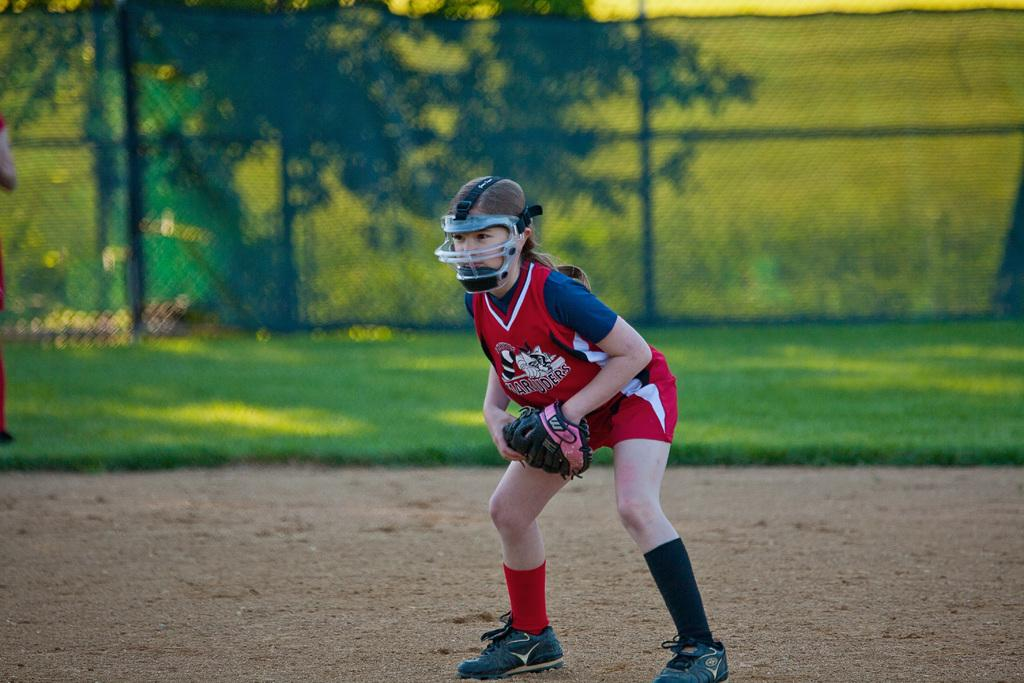What is the main subject in the foreground of the image? There is a woman in the foreground of the image. What is the woman doing in the image? The woman is standing in the image. What type of clothing or accessories is the woman wearing? The woman is wearing gloves, a helmet, and shoes in the image. What can be seen in the background of the image? There is greenery and fencing in the background of the image. What is visible at the woman's feet? The ground is visible in the foreground of the image. What type of scissors can be seen in the woman's hand in the image? There are no scissors visible in the woman's hand in the image. What type of jewel is the woman wearing around her neck in the image? There is no jewel visible around the woman's neck in the image. 